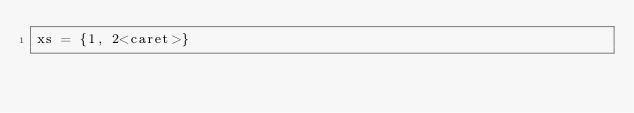<code> <loc_0><loc_0><loc_500><loc_500><_Python_>xs = {1, 2<caret>}</code> 